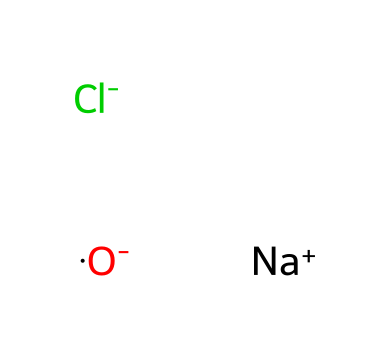What ions are present in this chemical structure? The SMILES representation shows sodium (Na) and chloride (Cl) ions, along with an oxygen ion. Therefore, the present ions are sodium and chloride, as identified from their respective notation in the SMILES.
Answer: sodium and chloride How many oxygen atoms are in this chemical? The SMILES shows one oxygen atom, as indicated by the presence of the "O" which stands for oxygen. There are no other oxygen representations in the structure.
Answer: one What is the overall charge of the molecule represented? In the chemical representation, sodium has a positive charge (+1), while chloride and oxygen have negative charges (-1 each). The total charge calculation leads to a net charge of zero (0) as positive and negative charges balance out.
Answer: zero Which type of compounds are represented by this structure? The presence of sodium and chloride ions indicates that this is an ionic compound, as it consists of cations and anions held together by ionic bonds, characteristic of salts.
Answer: ionic compound What is the role of chlorine in disinfectants? Chlorine acts as a powerful germicidal agent; its presence in disinfectants allows for the effective killing of bacteria and viruses due to its high reactivity, which disrupts the microbial cell's integrity.
Answer: germicidal agent How does the presence of oxygen affect the reactivity of disinfectants? The negatively charged oxygen in this structure suggests that it may enhance reactivity, as oxygen can participate in various chemical reactions, potentially aiding in the oxidative processes that help disinfect.
Answer: enhances reactivity 